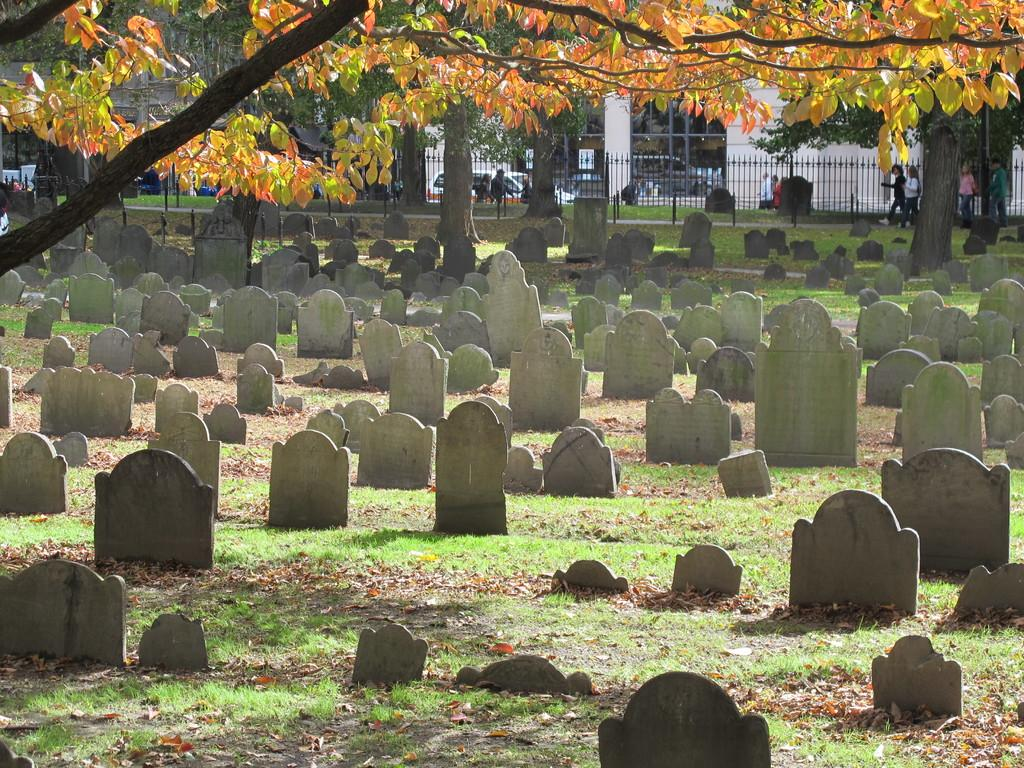What is the main setting of the image? The image depicts a graveyard. What can be seen in the background of the image? There is a railing, trees, vehicles, persons, and a building in the background. Can you describe the railing in the image? The railing is located in the background. What type of eggnog is being served at the graveyard in the image? There is no eggnog present in the image; it is a graveyard setting. How many boys are visible in the image? There is no mention of boys in the provided facts, so we cannot determine their presence in the image. 